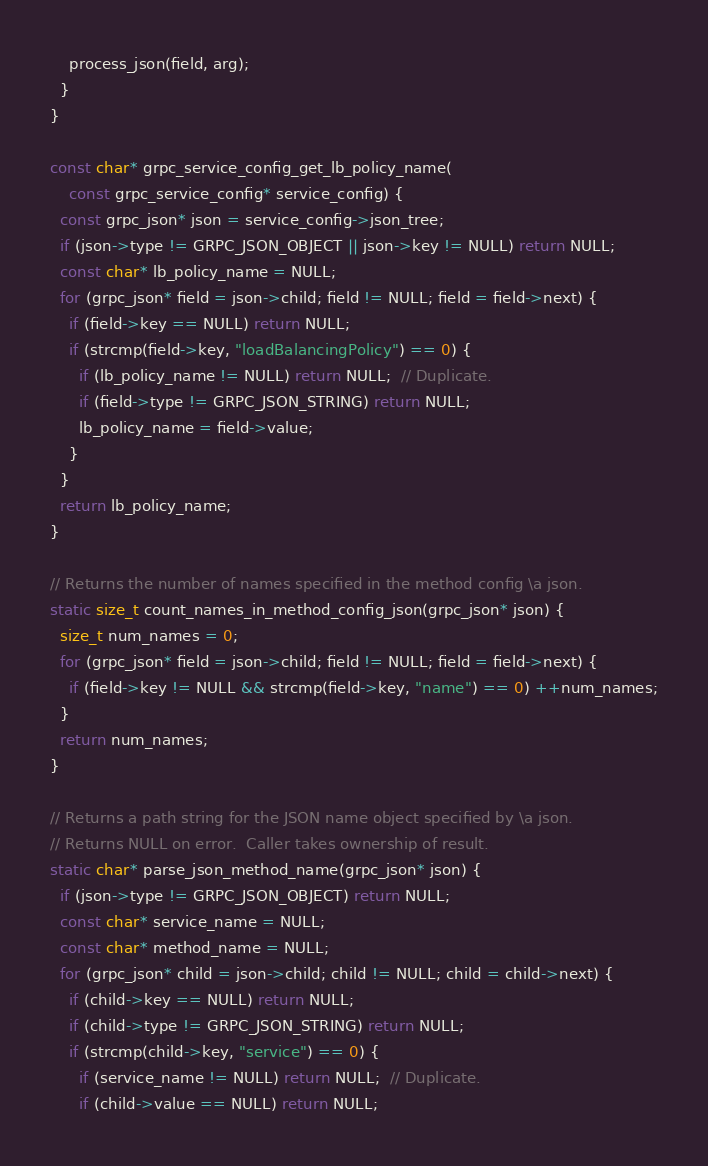<code> <loc_0><loc_0><loc_500><loc_500><_C_>    process_json(field, arg);
  }
}

const char* grpc_service_config_get_lb_policy_name(
    const grpc_service_config* service_config) {
  const grpc_json* json = service_config->json_tree;
  if (json->type != GRPC_JSON_OBJECT || json->key != NULL) return NULL;
  const char* lb_policy_name = NULL;
  for (grpc_json* field = json->child; field != NULL; field = field->next) {
    if (field->key == NULL) return NULL;
    if (strcmp(field->key, "loadBalancingPolicy") == 0) {
      if (lb_policy_name != NULL) return NULL;  // Duplicate.
      if (field->type != GRPC_JSON_STRING) return NULL;
      lb_policy_name = field->value;
    }
  }
  return lb_policy_name;
}

// Returns the number of names specified in the method config \a json.
static size_t count_names_in_method_config_json(grpc_json* json) {
  size_t num_names = 0;
  for (grpc_json* field = json->child; field != NULL; field = field->next) {
    if (field->key != NULL && strcmp(field->key, "name") == 0) ++num_names;
  }
  return num_names;
}

// Returns a path string for the JSON name object specified by \a json.
// Returns NULL on error.  Caller takes ownership of result.
static char* parse_json_method_name(grpc_json* json) {
  if (json->type != GRPC_JSON_OBJECT) return NULL;
  const char* service_name = NULL;
  const char* method_name = NULL;
  for (grpc_json* child = json->child; child != NULL; child = child->next) {
    if (child->key == NULL) return NULL;
    if (child->type != GRPC_JSON_STRING) return NULL;
    if (strcmp(child->key, "service") == 0) {
      if (service_name != NULL) return NULL;  // Duplicate.
      if (child->value == NULL) return NULL;</code> 